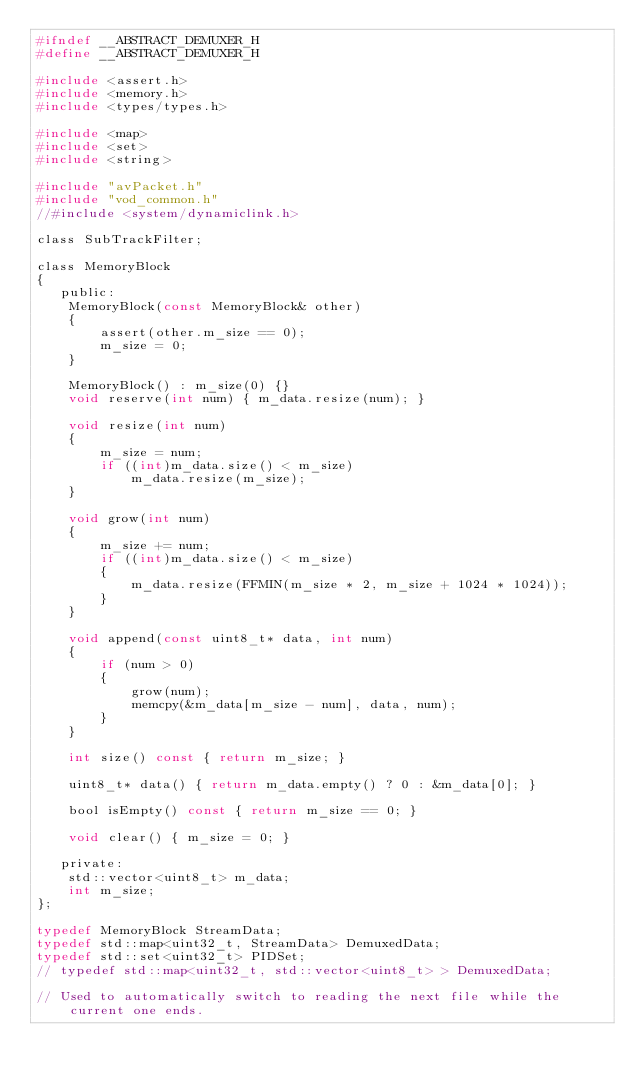<code> <loc_0><loc_0><loc_500><loc_500><_C_>#ifndef __ABSTRACT_DEMUXER_H
#define __ABSTRACT_DEMUXER_H

#include <assert.h>
#include <memory.h>
#include <types/types.h>

#include <map>
#include <set>
#include <string>

#include "avPacket.h"
#include "vod_common.h"
//#include <system/dynamiclink.h>

class SubTrackFilter;

class MemoryBlock
{
   public:
    MemoryBlock(const MemoryBlock& other)
    {
        assert(other.m_size == 0);
        m_size = 0;
    }

    MemoryBlock() : m_size(0) {}
    void reserve(int num) { m_data.resize(num); }

    void resize(int num)
    {
        m_size = num;
        if ((int)m_data.size() < m_size)
            m_data.resize(m_size);
    }

    void grow(int num)
    {
        m_size += num;
        if ((int)m_data.size() < m_size)
        {
            m_data.resize(FFMIN(m_size * 2, m_size + 1024 * 1024));
        }
    }

    void append(const uint8_t* data, int num)
    {
        if (num > 0)
        {
            grow(num);
            memcpy(&m_data[m_size - num], data, num);
        }
    }

    int size() const { return m_size; }

    uint8_t* data() { return m_data.empty() ? 0 : &m_data[0]; }

    bool isEmpty() const { return m_size == 0; }

    void clear() { m_size = 0; }

   private:
    std::vector<uint8_t> m_data;
    int m_size;
};

typedef MemoryBlock StreamData;
typedef std::map<uint32_t, StreamData> DemuxedData;
typedef std::set<uint32_t> PIDSet;
// typedef std::map<uint32_t, std::vector<uint8_t> > DemuxedData;

// Used to automatically switch to reading the next file while the current one ends.</code> 